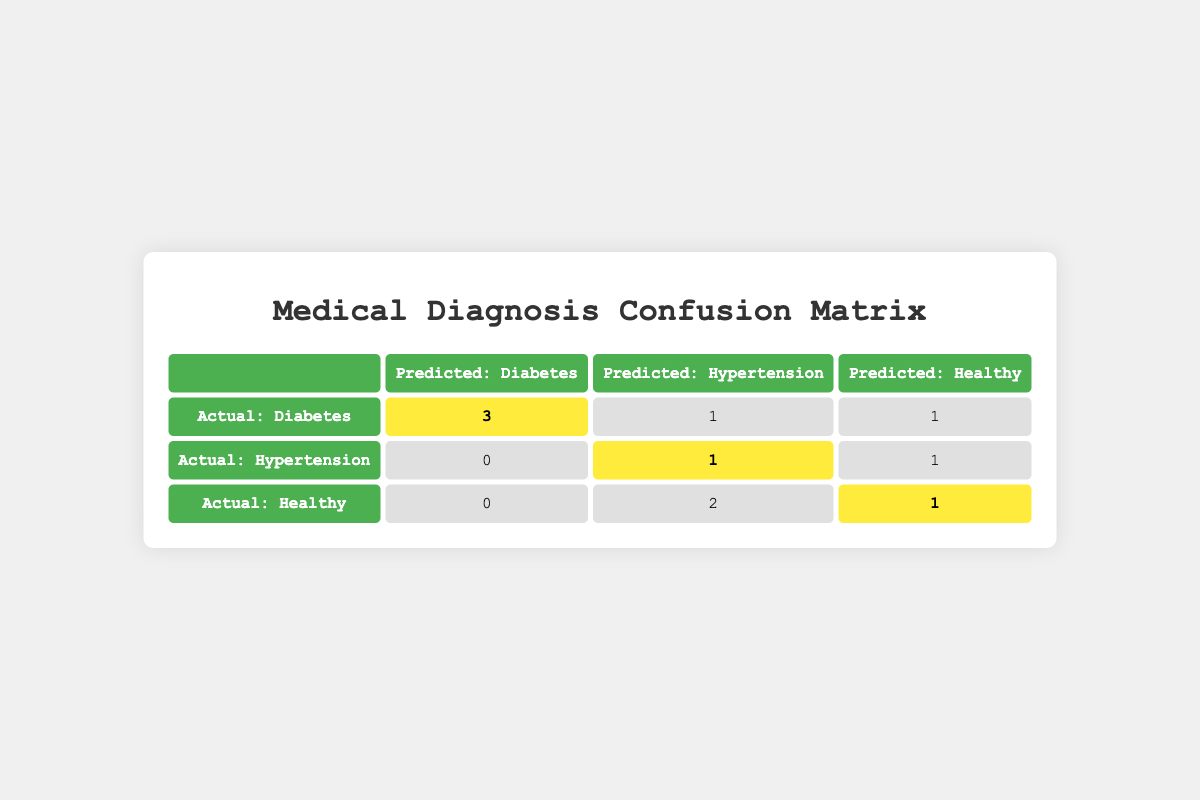What is the total number of patients diagnosed with Diabetes? From the table, under the row "Actual: Diabetes," we see three patients predicted to have Diabetes. Thus, the total number of patients diagnosed with Diabetes is 3.
Answer: 3 How many patients were falsely diagnosed with Hypertension when they actually had Diabetes? According to the table, there is one patient (patient_id 3) who was predicted to have Hypertension, but their actual outcome was Diabetes. This indicates a false diagnosis for Hypertension.
Answer: 1 What is the total number of patients with actual outcomes of Healthy? Looking at the "Actual: Healthy" row, we see two patients predicted to have Hypertension and one patient predicted to be Healthy. Hence, the total number of patients with actual outcomes of Healthy is 3 (2 + 1).
Answer: 3 Did any patients with a prediction of Diabetes actually have a Healthy diagnosis? Yes, there is one patient (patient_id 9) who was predicted to be Healthy but had a diagnosis of Diabetes. This confirms that there was a misclassification.
Answer: Yes What is the sum of actual outcomes for Hypertension that were predicted as Diabetes? Referring to the "Actual: Hypertension" row, there were no patients predicted as Diabetes, hence the sum is 0.
Answer: 0 How many total patients were correctly diagnosed across all conditions? The correct diagnoses include 4 patients diagnosed correctly as Diabetes (3 predicted to be Diabetes and 1 actually Diabetes) + 1 correctly diagnosed as Hypertension + 1 correctly diagnosed as Healthy, totaling 6.
Answer: 6 What is the ratio of correctly diagnosed Diabetes cases to incorrectly diagnosed cases? There are 3 correctly diagnosed Diabetes cases, and the misdiagnosed cases include 1 Hypertension patient predicted as Diabetes and 1 Healthy patient also misdiagnosed. So there are 2 incorrect cases. Therefore, the ratio is 3:2.
Answer: 3:2 How many patients were predicted as Healthy in total? Observing the predicted outcomes, we see that 3 patients were predicted to be Healthy (patient_id 6 and patient_id 10, and also patient_id 7 who was incorrectly diagnosed). Therefore, the total is 3.
Answer: 3 Were there more patients correctly diagnosed as Healthy or as Hypertension? There was 1 patient correctly diagnosed as Healthy and 1 correctly diagnosed as Hypertension, leading to a tie. So, neither condition has more correct diagnoses.
Answer: Tie 